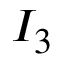Convert formula to latex. <formula><loc_0><loc_0><loc_500><loc_500>I _ { 3 }</formula> 